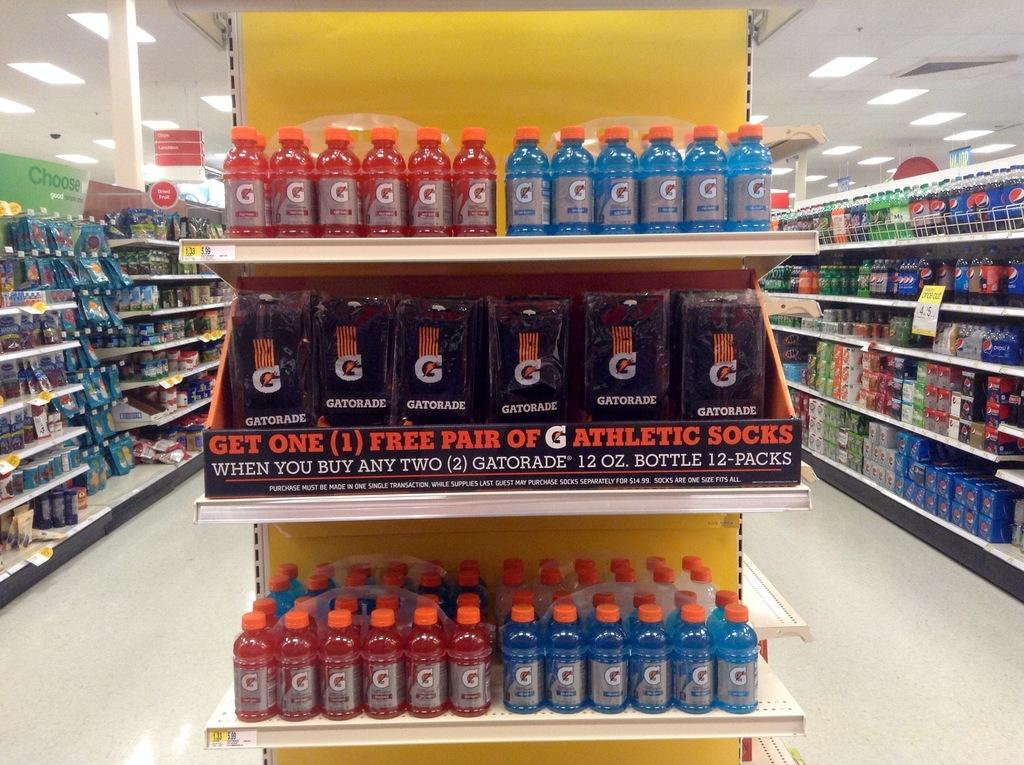<image>
Share a concise interpretation of the image provided. Different colored Gatorade bottles on display at a store. 